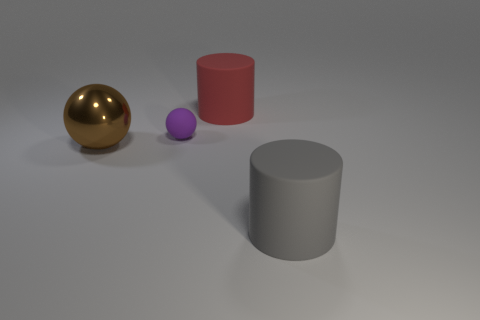Are there any other things that are made of the same material as the brown sphere?
Your answer should be compact. No. Is there a ball behind the large brown metal sphere that is left of the large rubber object that is on the right side of the big red thing?
Your answer should be very brief. Yes. There is a ball on the right side of the brown ball; is its size the same as the gray matte object?
Give a very brief answer. No. How many red matte cylinders have the same size as the brown thing?
Give a very brief answer. 1. The red thing has what shape?
Your answer should be compact. Cylinder. Is there a big thing that has the same color as the matte sphere?
Ensure brevity in your answer.  No. Are there more matte things on the left side of the large gray matte thing than gray matte things?
Offer a very short reply. Yes. There is a big gray matte thing; is its shape the same as the thing on the left side of the tiny purple matte sphere?
Keep it short and to the point. No. Are any large spheres visible?
Your answer should be compact. Yes. What number of large objects are either gray matte cylinders or brown rubber cylinders?
Provide a succinct answer. 1. 